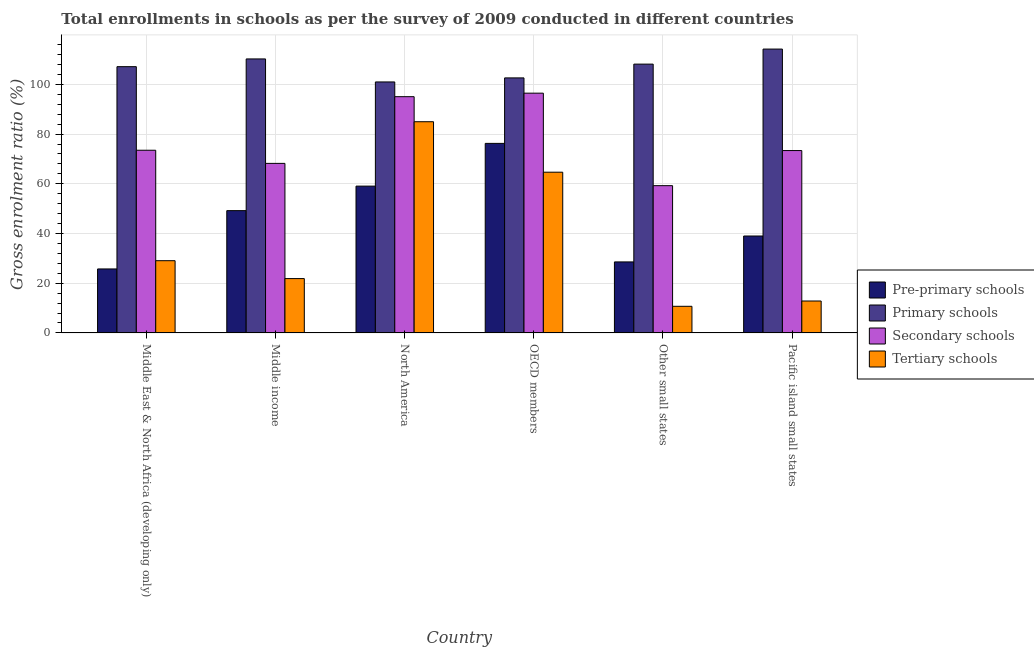How many different coloured bars are there?
Your response must be concise. 4. How many groups of bars are there?
Offer a terse response. 6. Are the number of bars per tick equal to the number of legend labels?
Ensure brevity in your answer.  Yes. Are the number of bars on each tick of the X-axis equal?
Make the answer very short. Yes. How many bars are there on the 3rd tick from the right?
Offer a very short reply. 4. What is the label of the 5th group of bars from the left?
Your answer should be very brief. Other small states. In how many cases, is the number of bars for a given country not equal to the number of legend labels?
Your response must be concise. 0. What is the gross enrolment ratio in tertiary schools in North America?
Offer a terse response. 84.97. Across all countries, what is the maximum gross enrolment ratio in tertiary schools?
Provide a succinct answer. 84.97. Across all countries, what is the minimum gross enrolment ratio in primary schools?
Offer a terse response. 100.98. In which country was the gross enrolment ratio in tertiary schools maximum?
Make the answer very short. North America. In which country was the gross enrolment ratio in pre-primary schools minimum?
Offer a terse response. Middle East & North Africa (developing only). What is the total gross enrolment ratio in secondary schools in the graph?
Offer a terse response. 465.86. What is the difference between the gross enrolment ratio in tertiary schools in Middle income and that in Pacific island small states?
Offer a terse response. 9.02. What is the difference between the gross enrolment ratio in pre-primary schools in Middle income and the gross enrolment ratio in primary schools in North America?
Ensure brevity in your answer.  -51.78. What is the average gross enrolment ratio in pre-primary schools per country?
Your answer should be compact. 46.31. What is the difference between the gross enrolment ratio in tertiary schools and gross enrolment ratio in secondary schools in OECD members?
Provide a short and direct response. -31.79. What is the ratio of the gross enrolment ratio in tertiary schools in North America to that in OECD members?
Offer a very short reply. 1.31. Is the gross enrolment ratio in pre-primary schools in Middle East & North Africa (developing only) less than that in OECD members?
Offer a very short reply. Yes. What is the difference between the highest and the second highest gross enrolment ratio in pre-primary schools?
Keep it short and to the point. 17.19. What is the difference between the highest and the lowest gross enrolment ratio in primary schools?
Provide a succinct answer. 13.22. Is the sum of the gross enrolment ratio in primary schools in Middle East & North Africa (developing only) and Middle income greater than the maximum gross enrolment ratio in pre-primary schools across all countries?
Offer a very short reply. Yes. What does the 3rd bar from the left in Other small states represents?
Offer a terse response. Secondary schools. What does the 3rd bar from the right in Pacific island small states represents?
Your answer should be compact. Primary schools. How many countries are there in the graph?
Provide a short and direct response. 6. Are the values on the major ticks of Y-axis written in scientific E-notation?
Make the answer very short. No. Does the graph contain any zero values?
Offer a very short reply. No. Does the graph contain grids?
Keep it short and to the point. Yes. What is the title of the graph?
Make the answer very short. Total enrollments in schools as per the survey of 2009 conducted in different countries. What is the label or title of the X-axis?
Offer a terse response. Country. What is the Gross enrolment ratio (%) in Pre-primary schools in Middle East & North Africa (developing only)?
Provide a succinct answer. 25.75. What is the Gross enrolment ratio (%) of Primary schools in Middle East & North Africa (developing only)?
Keep it short and to the point. 107.13. What is the Gross enrolment ratio (%) in Secondary schools in Middle East & North Africa (developing only)?
Provide a succinct answer. 73.5. What is the Gross enrolment ratio (%) in Tertiary schools in Middle East & North Africa (developing only)?
Ensure brevity in your answer.  29.06. What is the Gross enrolment ratio (%) of Pre-primary schools in Middle income?
Your response must be concise. 49.2. What is the Gross enrolment ratio (%) of Primary schools in Middle income?
Provide a short and direct response. 110.24. What is the Gross enrolment ratio (%) in Secondary schools in Middle income?
Offer a very short reply. 68.21. What is the Gross enrolment ratio (%) in Tertiary schools in Middle income?
Your answer should be compact. 21.86. What is the Gross enrolment ratio (%) in Pre-primary schools in North America?
Give a very brief answer. 59.07. What is the Gross enrolment ratio (%) of Primary schools in North America?
Ensure brevity in your answer.  100.98. What is the Gross enrolment ratio (%) in Secondary schools in North America?
Your response must be concise. 95.05. What is the Gross enrolment ratio (%) in Tertiary schools in North America?
Provide a short and direct response. 84.97. What is the Gross enrolment ratio (%) in Pre-primary schools in OECD members?
Your response must be concise. 76.26. What is the Gross enrolment ratio (%) of Primary schools in OECD members?
Provide a short and direct response. 102.61. What is the Gross enrolment ratio (%) in Secondary schools in OECD members?
Ensure brevity in your answer.  96.46. What is the Gross enrolment ratio (%) of Tertiary schools in OECD members?
Keep it short and to the point. 64.67. What is the Gross enrolment ratio (%) of Pre-primary schools in Other small states?
Your response must be concise. 28.57. What is the Gross enrolment ratio (%) in Primary schools in Other small states?
Provide a succinct answer. 108.15. What is the Gross enrolment ratio (%) of Secondary schools in Other small states?
Provide a succinct answer. 59.25. What is the Gross enrolment ratio (%) in Tertiary schools in Other small states?
Keep it short and to the point. 10.72. What is the Gross enrolment ratio (%) of Pre-primary schools in Pacific island small states?
Your response must be concise. 38.99. What is the Gross enrolment ratio (%) in Primary schools in Pacific island small states?
Your answer should be compact. 114.2. What is the Gross enrolment ratio (%) of Secondary schools in Pacific island small states?
Provide a succinct answer. 73.38. What is the Gross enrolment ratio (%) in Tertiary schools in Pacific island small states?
Provide a short and direct response. 12.84. Across all countries, what is the maximum Gross enrolment ratio (%) of Pre-primary schools?
Offer a very short reply. 76.26. Across all countries, what is the maximum Gross enrolment ratio (%) in Primary schools?
Provide a short and direct response. 114.2. Across all countries, what is the maximum Gross enrolment ratio (%) of Secondary schools?
Your answer should be very brief. 96.46. Across all countries, what is the maximum Gross enrolment ratio (%) in Tertiary schools?
Keep it short and to the point. 84.97. Across all countries, what is the minimum Gross enrolment ratio (%) in Pre-primary schools?
Provide a succinct answer. 25.75. Across all countries, what is the minimum Gross enrolment ratio (%) of Primary schools?
Your answer should be very brief. 100.98. Across all countries, what is the minimum Gross enrolment ratio (%) of Secondary schools?
Ensure brevity in your answer.  59.25. Across all countries, what is the minimum Gross enrolment ratio (%) in Tertiary schools?
Provide a succinct answer. 10.72. What is the total Gross enrolment ratio (%) in Pre-primary schools in the graph?
Your answer should be compact. 277.84. What is the total Gross enrolment ratio (%) in Primary schools in the graph?
Provide a short and direct response. 643.3. What is the total Gross enrolment ratio (%) in Secondary schools in the graph?
Offer a terse response. 465.86. What is the total Gross enrolment ratio (%) of Tertiary schools in the graph?
Ensure brevity in your answer.  224.13. What is the difference between the Gross enrolment ratio (%) of Pre-primary schools in Middle East & North Africa (developing only) and that in Middle income?
Your answer should be compact. -23.45. What is the difference between the Gross enrolment ratio (%) of Primary schools in Middle East & North Africa (developing only) and that in Middle income?
Your answer should be very brief. -3.11. What is the difference between the Gross enrolment ratio (%) in Secondary schools in Middle East & North Africa (developing only) and that in Middle income?
Offer a very short reply. 5.29. What is the difference between the Gross enrolment ratio (%) in Tertiary schools in Middle East & North Africa (developing only) and that in Middle income?
Provide a succinct answer. 7.2. What is the difference between the Gross enrolment ratio (%) of Pre-primary schools in Middle East & North Africa (developing only) and that in North America?
Provide a succinct answer. -33.32. What is the difference between the Gross enrolment ratio (%) of Primary schools in Middle East & North Africa (developing only) and that in North America?
Your answer should be very brief. 6.15. What is the difference between the Gross enrolment ratio (%) in Secondary schools in Middle East & North Africa (developing only) and that in North America?
Your response must be concise. -21.55. What is the difference between the Gross enrolment ratio (%) of Tertiary schools in Middle East & North Africa (developing only) and that in North America?
Give a very brief answer. -55.91. What is the difference between the Gross enrolment ratio (%) of Pre-primary schools in Middle East & North Africa (developing only) and that in OECD members?
Give a very brief answer. -50.51. What is the difference between the Gross enrolment ratio (%) in Primary schools in Middle East & North Africa (developing only) and that in OECD members?
Offer a very short reply. 4.52. What is the difference between the Gross enrolment ratio (%) in Secondary schools in Middle East & North Africa (developing only) and that in OECD members?
Your answer should be very brief. -22.96. What is the difference between the Gross enrolment ratio (%) of Tertiary schools in Middle East & North Africa (developing only) and that in OECD members?
Your answer should be compact. -35.61. What is the difference between the Gross enrolment ratio (%) in Pre-primary schools in Middle East & North Africa (developing only) and that in Other small states?
Offer a very short reply. -2.82. What is the difference between the Gross enrolment ratio (%) of Primary schools in Middle East & North Africa (developing only) and that in Other small states?
Make the answer very short. -1.03. What is the difference between the Gross enrolment ratio (%) in Secondary schools in Middle East & North Africa (developing only) and that in Other small states?
Offer a terse response. 14.25. What is the difference between the Gross enrolment ratio (%) of Tertiary schools in Middle East & North Africa (developing only) and that in Other small states?
Your response must be concise. 18.35. What is the difference between the Gross enrolment ratio (%) of Pre-primary schools in Middle East & North Africa (developing only) and that in Pacific island small states?
Your answer should be very brief. -13.25. What is the difference between the Gross enrolment ratio (%) of Primary schools in Middle East & North Africa (developing only) and that in Pacific island small states?
Provide a succinct answer. -7.08. What is the difference between the Gross enrolment ratio (%) of Secondary schools in Middle East & North Africa (developing only) and that in Pacific island small states?
Provide a succinct answer. 0.12. What is the difference between the Gross enrolment ratio (%) of Tertiary schools in Middle East & North Africa (developing only) and that in Pacific island small states?
Keep it short and to the point. 16.22. What is the difference between the Gross enrolment ratio (%) in Pre-primary schools in Middle income and that in North America?
Your answer should be compact. -9.87. What is the difference between the Gross enrolment ratio (%) in Primary schools in Middle income and that in North America?
Give a very brief answer. 9.26. What is the difference between the Gross enrolment ratio (%) in Secondary schools in Middle income and that in North America?
Your answer should be compact. -26.84. What is the difference between the Gross enrolment ratio (%) of Tertiary schools in Middle income and that in North America?
Provide a succinct answer. -63.11. What is the difference between the Gross enrolment ratio (%) of Pre-primary schools in Middle income and that in OECD members?
Your response must be concise. -27.06. What is the difference between the Gross enrolment ratio (%) of Primary schools in Middle income and that in OECD members?
Offer a very short reply. 7.63. What is the difference between the Gross enrolment ratio (%) in Secondary schools in Middle income and that in OECD members?
Offer a very short reply. -28.25. What is the difference between the Gross enrolment ratio (%) in Tertiary schools in Middle income and that in OECD members?
Offer a very short reply. -42.8. What is the difference between the Gross enrolment ratio (%) in Pre-primary schools in Middle income and that in Other small states?
Provide a short and direct response. 20.63. What is the difference between the Gross enrolment ratio (%) of Primary schools in Middle income and that in Other small states?
Provide a succinct answer. 2.09. What is the difference between the Gross enrolment ratio (%) in Secondary schools in Middle income and that in Other small states?
Your answer should be very brief. 8.96. What is the difference between the Gross enrolment ratio (%) of Tertiary schools in Middle income and that in Other small states?
Your response must be concise. 11.15. What is the difference between the Gross enrolment ratio (%) of Pre-primary schools in Middle income and that in Pacific island small states?
Make the answer very short. 10.21. What is the difference between the Gross enrolment ratio (%) of Primary schools in Middle income and that in Pacific island small states?
Your response must be concise. -3.97. What is the difference between the Gross enrolment ratio (%) in Secondary schools in Middle income and that in Pacific island small states?
Your response must be concise. -5.17. What is the difference between the Gross enrolment ratio (%) in Tertiary schools in Middle income and that in Pacific island small states?
Keep it short and to the point. 9.02. What is the difference between the Gross enrolment ratio (%) in Pre-primary schools in North America and that in OECD members?
Provide a succinct answer. -17.19. What is the difference between the Gross enrolment ratio (%) in Primary schools in North America and that in OECD members?
Your answer should be compact. -1.63. What is the difference between the Gross enrolment ratio (%) of Secondary schools in North America and that in OECD members?
Provide a short and direct response. -1.41. What is the difference between the Gross enrolment ratio (%) of Tertiary schools in North America and that in OECD members?
Provide a succinct answer. 20.31. What is the difference between the Gross enrolment ratio (%) in Pre-primary schools in North America and that in Other small states?
Provide a short and direct response. 30.5. What is the difference between the Gross enrolment ratio (%) in Primary schools in North America and that in Other small states?
Offer a terse response. -7.17. What is the difference between the Gross enrolment ratio (%) in Secondary schools in North America and that in Other small states?
Give a very brief answer. 35.8. What is the difference between the Gross enrolment ratio (%) in Tertiary schools in North America and that in Other small states?
Offer a terse response. 74.26. What is the difference between the Gross enrolment ratio (%) of Pre-primary schools in North America and that in Pacific island small states?
Provide a succinct answer. 20.07. What is the difference between the Gross enrolment ratio (%) of Primary schools in North America and that in Pacific island small states?
Keep it short and to the point. -13.22. What is the difference between the Gross enrolment ratio (%) of Secondary schools in North America and that in Pacific island small states?
Provide a short and direct response. 21.67. What is the difference between the Gross enrolment ratio (%) in Tertiary schools in North America and that in Pacific island small states?
Provide a short and direct response. 72.13. What is the difference between the Gross enrolment ratio (%) of Pre-primary schools in OECD members and that in Other small states?
Keep it short and to the point. 47.69. What is the difference between the Gross enrolment ratio (%) of Primary schools in OECD members and that in Other small states?
Your response must be concise. -5.54. What is the difference between the Gross enrolment ratio (%) in Secondary schools in OECD members and that in Other small states?
Keep it short and to the point. 37.21. What is the difference between the Gross enrolment ratio (%) of Tertiary schools in OECD members and that in Other small states?
Your response must be concise. 53.95. What is the difference between the Gross enrolment ratio (%) in Pre-primary schools in OECD members and that in Pacific island small states?
Your answer should be compact. 37.27. What is the difference between the Gross enrolment ratio (%) in Primary schools in OECD members and that in Pacific island small states?
Ensure brevity in your answer.  -11.6. What is the difference between the Gross enrolment ratio (%) in Secondary schools in OECD members and that in Pacific island small states?
Offer a terse response. 23.08. What is the difference between the Gross enrolment ratio (%) of Tertiary schools in OECD members and that in Pacific island small states?
Offer a very short reply. 51.82. What is the difference between the Gross enrolment ratio (%) in Pre-primary schools in Other small states and that in Pacific island small states?
Offer a terse response. -10.42. What is the difference between the Gross enrolment ratio (%) in Primary schools in Other small states and that in Pacific island small states?
Ensure brevity in your answer.  -6.05. What is the difference between the Gross enrolment ratio (%) in Secondary schools in Other small states and that in Pacific island small states?
Your response must be concise. -14.13. What is the difference between the Gross enrolment ratio (%) in Tertiary schools in Other small states and that in Pacific island small states?
Ensure brevity in your answer.  -2.13. What is the difference between the Gross enrolment ratio (%) in Pre-primary schools in Middle East & North Africa (developing only) and the Gross enrolment ratio (%) in Primary schools in Middle income?
Provide a succinct answer. -84.49. What is the difference between the Gross enrolment ratio (%) in Pre-primary schools in Middle East & North Africa (developing only) and the Gross enrolment ratio (%) in Secondary schools in Middle income?
Offer a terse response. -42.46. What is the difference between the Gross enrolment ratio (%) of Pre-primary schools in Middle East & North Africa (developing only) and the Gross enrolment ratio (%) of Tertiary schools in Middle income?
Make the answer very short. 3.88. What is the difference between the Gross enrolment ratio (%) of Primary schools in Middle East & North Africa (developing only) and the Gross enrolment ratio (%) of Secondary schools in Middle income?
Provide a succinct answer. 38.91. What is the difference between the Gross enrolment ratio (%) in Primary schools in Middle East & North Africa (developing only) and the Gross enrolment ratio (%) in Tertiary schools in Middle income?
Provide a short and direct response. 85.26. What is the difference between the Gross enrolment ratio (%) of Secondary schools in Middle East & North Africa (developing only) and the Gross enrolment ratio (%) of Tertiary schools in Middle income?
Offer a very short reply. 51.64. What is the difference between the Gross enrolment ratio (%) in Pre-primary schools in Middle East & North Africa (developing only) and the Gross enrolment ratio (%) in Primary schools in North America?
Make the answer very short. -75.23. What is the difference between the Gross enrolment ratio (%) of Pre-primary schools in Middle East & North Africa (developing only) and the Gross enrolment ratio (%) of Secondary schools in North America?
Your response must be concise. -69.3. What is the difference between the Gross enrolment ratio (%) in Pre-primary schools in Middle East & North Africa (developing only) and the Gross enrolment ratio (%) in Tertiary schools in North America?
Ensure brevity in your answer.  -59.23. What is the difference between the Gross enrolment ratio (%) in Primary schools in Middle East & North Africa (developing only) and the Gross enrolment ratio (%) in Secondary schools in North America?
Make the answer very short. 12.07. What is the difference between the Gross enrolment ratio (%) of Primary schools in Middle East & North Africa (developing only) and the Gross enrolment ratio (%) of Tertiary schools in North America?
Your answer should be very brief. 22.15. What is the difference between the Gross enrolment ratio (%) in Secondary schools in Middle East & North Africa (developing only) and the Gross enrolment ratio (%) in Tertiary schools in North America?
Provide a short and direct response. -11.47. What is the difference between the Gross enrolment ratio (%) of Pre-primary schools in Middle East & North Africa (developing only) and the Gross enrolment ratio (%) of Primary schools in OECD members?
Keep it short and to the point. -76.86. What is the difference between the Gross enrolment ratio (%) of Pre-primary schools in Middle East & North Africa (developing only) and the Gross enrolment ratio (%) of Secondary schools in OECD members?
Keep it short and to the point. -70.71. What is the difference between the Gross enrolment ratio (%) of Pre-primary schools in Middle East & North Africa (developing only) and the Gross enrolment ratio (%) of Tertiary schools in OECD members?
Provide a short and direct response. -38.92. What is the difference between the Gross enrolment ratio (%) in Primary schools in Middle East & North Africa (developing only) and the Gross enrolment ratio (%) in Secondary schools in OECD members?
Keep it short and to the point. 10.66. What is the difference between the Gross enrolment ratio (%) of Primary schools in Middle East & North Africa (developing only) and the Gross enrolment ratio (%) of Tertiary schools in OECD members?
Your response must be concise. 42.46. What is the difference between the Gross enrolment ratio (%) in Secondary schools in Middle East & North Africa (developing only) and the Gross enrolment ratio (%) in Tertiary schools in OECD members?
Offer a very short reply. 8.83. What is the difference between the Gross enrolment ratio (%) of Pre-primary schools in Middle East & North Africa (developing only) and the Gross enrolment ratio (%) of Primary schools in Other small states?
Your answer should be very brief. -82.4. What is the difference between the Gross enrolment ratio (%) of Pre-primary schools in Middle East & North Africa (developing only) and the Gross enrolment ratio (%) of Secondary schools in Other small states?
Provide a succinct answer. -33.5. What is the difference between the Gross enrolment ratio (%) in Pre-primary schools in Middle East & North Africa (developing only) and the Gross enrolment ratio (%) in Tertiary schools in Other small states?
Keep it short and to the point. 15.03. What is the difference between the Gross enrolment ratio (%) of Primary schools in Middle East & North Africa (developing only) and the Gross enrolment ratio (%) of Secondary schools in Other small states?
Offer a very short reply. 47.87. What is the difference between the Gross enrolment ratio (%) in Primary schools in Middle East & North Africa (developing only) and the Gross enrolment ratio (%) in Tertiary schools in Other small states?
Keep it short and to the point. 96.41. What is the difference between the Gross enrolment ratio (%) of Secondary schools in Middle East & North Africa (developing only) and the Gross enrolment ratio (%) of Tertiary schools in Other small states?
Offer a very short reply. 62.78. What is the difference between the Gross enrolment ratio (%) of Pre-primary schools in Middle East & North Africa (developing only) and the Gross enrolment ratio (%) of Primary schools in Pacific island small states?
Your response must be concise. -88.46. What is the difference between the Gross enrolment ratio (%) in Pre-primary schools in Middle East & North Africa (developing only) and the Gross enrolment ratio (%) in Secondary schools in Pacific island small states?
Ensure brevity in your answer.  -47.63. What is the difference between the Gross enrolment ratio (%) of Pre-primary schools in Middle East & North Africa (developing only) and the Gross enrolment ratio (%) of Tertiary schools in Pacific island small states?
Your answer should be very brief. 12.9. What is the difference between the Gross enrolment ratio (%) in Primary schools in Middle East & North Africa (developing only) and the Gross enrolment ratio (%) in Secondary schools in Pacific island small states?
Provide a succinct answer. 33.75. What is the difference between the Gross enrolment ratio (%) of Primary schools in Middle East & North Africa (developing only) and the Gross enrolment ratio (%) of Tertiary schools in Pacific island small states?
Offer a terse response. 94.28. What is the difference between the Gross enrolment ratio (%) in Secondary schools in Middle East & North Africa (developing only) and the Gross enrolment ratio (%) in Tertiary schools in Pacific island small states?
Your answer should be compact. 60.66. What is the difference between the Gross enrolment ratio (%) of Pre-primary schools in Middle income and the Gross enrolment ratio (%) of Primary schools in North America?
Provide a short and direct response. -51.78. What is the difference between the Gross enrolment ratio (%) in Pre-primary schools in Middle income and the Gross enrolment ratio (%) in Secondary schools in North America?
Offer a terse response. -45.85. What is the difference between the Gross enrolment ratio (%) of Pre-primary schools in Middle income and the Gross enrolment ratio (%) of Tertiary schools in North America?
Offer a terse response. -35.77. What is the difference between the Gross enrolment ratio (%) of Primary schools in Middle income and the Gross enrolment ratio (%) of Secondary schools in North America?
Your response must be concise. 15.19. What is the difference between the Gross enrolment ratio (%) in Primary schools in Middle income and the Gross enrolment ratio (%) in Tertiary schools in North America?
Make the answer very short. 25.26. What is the difference between the Gross enrolment ratio (%) in Secondary schools in Middle income and the Gross enrolment ratio (%) in Tertiary schools in North America?
Ensure brevity in your answer.  -16.76. What is the difference between the Gross enrolment ratio (%) in Pre-primary schools in Middle income and the Gross enrolment ratio (%) in Primary schools in OECD members?
Give a very brief answer. -53.4. What is the difference between the Gross enrolment ratio (%) of Pre-primary schools in Middle income and the Gross enrolment ratio (%) of Secondary schools in OECD members?
Keep it short and to the point. -47.26. What is the difference between the Gross enrolment ratio (%) of Pre-primary schools in Middle income and the Gross enrolment ratio (%) of Tertiary schools in OECD members?
Ensure brevity in your answer.  -15.47. What is the difference between the Gross enrolment ratio (%) of Primary schools in Middle income and the Gross enrolment ratio (%) of Secondary schools in OECD members?
Your answer should be very brief. 13.78. What is the difference between the Gross enrolment ratio (%) of Primary schools in Middle income and the Gross enrolment ratio (%) of Tertiary schools in OECD members?
Give a very brief answer. 45.57. What is the difference between the Gross enrolment ratio (%) of Secondary schools in Middle income and the Gross enrolment ratio (%) of Tertiary schools in OECD members?
Give a very brief answer. 3.54. What is the difference between the Gross enrolment ratio (%) in Pre-primary schools in Middle income and the Gross enrolment ratio (%) in Primary schools in Other small states?
Give a very brief answer. -58.95. What is the difference between the Gross enrolment ratio (%) of Pre-primary schools in Middle income and the Gross enrolment ratio (%) of Secondary schools in Other small states?
Provide a succinct answer. -10.05. What is the difference between the Gross enrolment ratio (%) in Pre-primary schools in Middle income and the Gross enrolment ratio (%) in Tertiary schools in Other small states?
Your response must be concise. 38.49. What is the difference between the Gross enrolment ratio (%) of Primary schools in Middle income and the Gross enrolment ratio (%) of Secondary schools in Other small states?
Offer a terse response. 50.99. What is the difference between the Gross enrolment ratio (%) in Primary schools in Middle income and the Gross enrolment ratio (%) in Tertiary schools in Other small states?
Make the answer very short. 99.52. What is the difference between the Gross enrolment ratio (%) of Secondary schools in Middle income and the Gross enrolment ratio (%) of Tertiary schools in Other small states?
Offer a terse response. 57.49. What is the difference between the Gross enrolment ratio (%) in Pre-primary schools in Middle income and the Gross enrolment ratio (%) in Primary schools in Pacific island small states?
Make the answer very short. -65. What is the difference between the Gross enrolment ratio (%) in Pre-primary schools in Middle income and the Gross enrolment ratio (%) in Secondary schools in Pacific island small states?
Offer a very short reply. -24.18. What is the difference between the Gross enrolment ratio (%) of Pre-primary schools in Middle income and the Gross enrolment ratio (%) of Tertiary schools in Pacific island small states?
Your answer should be very brief. 36.36. What is the difference between the Gross enrolment ratio (%) in Primary schools in Middle income and the Gross enrolment ratio (%) in Secondary schools in Pacific island small states?
Ensure brevity in your answer.  36.86. What is the difference between the Gross enrolment ratio (%) of Primary schools in Middle income and the Gross enrolment ratio (%) of Tertiary schools in Pacific island small states?
Provide a succinct answer. 97.39. What is the difference between the Gross enrolment ratio (%) in Secondary schools in Middle income and the Gross enrolment ratio (%) in Tertiary schools in Pacific island small states?
Your answer should be compact. 55.37. What is the difference between the Gross enrolment ratio (%) of Pre-primary schools in North America and the Gross enrolment ratio (%) of Primary schools in OECD members?
Offer a terse response. -43.54. What is the difference between the Gross enrolment ratio (%) of Pre-primary schools in North America and the Gross enrolment ratio (%) of Secondary schools in OECD members?
Keep it short and to the point. -37.39. What is the difference between the Gross enrolment ratio (%) in Pre-primary schools in North America and the Gross enrolment ratio (%) in Tertiary schools in OECD members?
Offer a terse response. -5.6. What is the difference between the Gross enrolment ratio (%) of Primary schools in North America and the Gross enrolment ratio (%) of Secondary schools in OECD members?
Provide a short and direct response. 4.52. What is the difference between the Gross enrolment ratio (%) in Primary schools in North America and the Gross enrolment ratio (%) in Tertiary schools in OECD members?
Keep it short and to the point. 36.31. What is the difference between the Gross enrolment ratio (%) in Secondary schools in North America and the Gross enrolment ratio (%) in Tertiary schools in OECD members?
Keep it short and to the point. 30.38. What is the difference between the Gross enrolment ratio (%) of Pre-primary schools in North America and the Gross enrolment ratio (%) of Primary schools in Other small states?
Provide a succinct answer. -49.08. What is the difference between the Gross enrolment ratio (%) of Pre-primary schools in North America and the Gross enrolment ratio (%) of Secondary schools in Other small states?
Provide a succinct answer. -0.18. What is the difference between the Gross enrolment ratio (%) of Pre-primary schools in North America and the Gross enrolment ratio (%) of Tertiary schools in Other small states?
Offer a terse response. 48.35. What is the difference between the Gross enrolment ratio (%) in Primary schools in North America and the Gross enrolment ratio (%) in Secondary schools in Other small states?
Make the answer very short. 41.73. What is the difference between the Gross enrolment ratio (%) of Primary schools in North America and the Gross enrolment ratio (%) of Tertiary schools in Other small states?
Ensure brevity in your answer.  90.26. What is the difference between the Gross enrolment ratio (%) in Secondary schools in North America and the Gross enrolment ratio (%) in Tertiary schools in Other small states?
Offer a very short reply. 84.33. What is the difference between the Gross enrolment ratio (%) in Pre-primary schools in North America and the Gross enrolment ratio (%) in Primary schools in Pacific island small states?
Keep it short and to the point. -55.14. What is the difference between the Gross enrolment ratio (%) of Pre-primary schools in North America and the Gross enrolment ratio (%) of Secondary schools in Pacific island small states?
Make the answer very short. -14.31. What is the difference between the Gross enrolment ratio (%) in Pre-primary schools in North America and the Gross enrolment ratio (%) in Tertiary schools in Pacific island small states?
Give a very brief answer. 46.22. What is the difference between the Gross enrolment ratio (%) of Primary schools in North America and the Gross enrolment ratio (%) of Secondary schools in Pacific island small states?
Ensure brevity in your answer.  27.6. What is the difference between the Gross enrolment ratio (%) in Primary schools in North America and the Gross enrolment ratio (%) in Tertiary schools in Pacific island small states?
Keep it short and to the point. 88.14. What is the difference between the Gross enrolment ratio (%) of Secondary schools in North America and the Gross enrolment ratio (%) of Tertiary schools in Pacific island small states?
Ensure brevity in your answer.  82.21. What is the difference between the Gross enrolment ratio (%) of Pre-primary schools in OECD members and the Gross enrolment ratio (%) of Primary schools in Other small states?
Your response must be concise. -31.89. What is the difference between the Gross enrolment ratio (%) in Pre-primary schools in OECD members and the Gross enrolment ratio (%) in Secondary schools in Other small states?
Your response must be concise. 17.01. What is the difference between the Gross enrolment ratio (%) of Pre-primary schools in OECD members and the Gross enrolment ratio (%) of Tertiary schools in Other small states?
Provide a succinct answer. 65.54. What is the difference between the Gross enrolment ratio (%) of Primary schools in OECD members and the Gross enrolment ratio (%) of Secondary schools in Other small states?
Your answer should be very brief. 43.36. What is the difference between the Gross enrolment ratio (%) in Primary schools in OECD members and the Gross enrolment ratio (%) in Tertiary schools in Other small states?
Your response must be concise. 91.89. What is the difference between the Gross enrolment ratio (%) of Secondary schools in OECD members and the Gross enrolment ratio (%) of Tertiary schools in Other small states?
Provide a succinct answer. 85.74. What is the difference between the Gross enrolment ratio (%) in Pre-primary schools in OECD members and the Gross enrolment ratio (%) in Primary schools in Pacific island small states?
Provide a short and direct response. -37.94. What is the difference between the Gross enrolment ratio (%) in Pre-primary schools in OECD members and the Gross enrolment ratio (%) in Secondary schools in Pacific island small states?
Give a very brief answer. 2.88. What is the difference between the Gross enrolment ratio (%) of Pre-primary schools in OECD members and the Gross enrolment ratio (%) of Tertiary schools in Pacific island small states?
Provide a succinct answer. 63.41. What is the difference between the Gross enrolment ratio (%) of Primary schools in OECD members and the Gross enrolment ratio (%) of Secondary schools in Pacific island small states?
Give a very brief answer. 29.23. What is the difference between the Gross enrolment ratio (%) in Primary schools in OECD members and the Gross enrolment ratio (%) in Tertiary schools in Pacific island small states?
Provide a succinct answer. 89.76. What is the difference between the Gross enrolment ratio (%) in Secondary schools in OECD members and the Gross enrolment ratio (%) in Tertiary schools in Pacific island small states?
Give a very brief answer. 83.62. What is the difference between the Gross enrolment ratio (%) of Pre-primary schools in Other small states and the Gross enrolment ratio (%) of Primary schools in Pacific island small states?
Provide a succinct answer. -85.63. What is the difference between the Gross enrolment ratio (%) in Pre-primary schools in Other small states and the Gross enrolment ratio (%) in Secondary schools in Pacific island small states?
Give a very brief answer. -44.81. What is the difference between the Gross enrolment ratio (%) of Pre-primary schools in Other small states and the Gross enrolment ratio (%) of Tertiary schools in Pacific island small states?
Give a very brief answer. 15.73. What is the difference between the Gross enrolment ratio (%) of Primary schools in Other small states and the Gross enrolment ratio (%) of Secondary schools in Pacific island small states?
Your answer should be very brief. 34.77. What is the difference between the Gross enrolment ratio (%) of Primary schools in Other small states and the Gross enrolment ratio (%) of Tertiary schools in Pacific island small states?
Offer a terse response. 95.31. What is the difference between the Gross enrolment ratio (%) of Secondary schools in Other small states and the Gross enrolment ratio (%) of Tertiary schools in Pacific island small states?
Provide a succinct answer. 46.41. What is the average Gross enrolment ratio (%) in Pre-primary schools per country?
Keep it short and to the point. 46.31. What is the average Gross enrolment ratio (%) of Primary schools per country?
Ensure brevity in your answer.  107.22. What is the average Gross enrolment ratio (%) of Secondary schools per country?
Offer a very short reply. 77.64. What is the average Gross enrolment ratio (%) in Tertiary schools per country?
Give a very brief answer. 37.36. What is the difference between the Gross enrolment ratio (%) of Pre-primary schools and Gross enrolment ratio (%) of Primary schools in Middle East & North Africa (developing only)?
Provide a short and direct response. -81.38. What is the difference between the Gross enrolment ratio (%) in Pre-primary schools and Gross enrolment ratio (%) in Secondary schools in Middle East & North Africa (developing only)?
Provide a short and direct response. -47.75. What is the difference between the Gross enrolment ratio (%) of Pre-primary schools and Gross enrolment ratio (%) of Tertiary schools in Middle East & North Africa (developing only)?
Offer a terse response. -3.32. What is the difference between the Gross enrolment ratio (%) in Primary schools and Gross enrolment ratio (%) in Secondary schools in Middle East & North Africa (developing only)?
Make the answer very short. 33.62. What is the difference between the Gross enrolment ratio (%) of Primary schools and Gross enrolment ratio (%) of Tertiary schools in Middle East & North Africa (developing only)?
Offer a very short reply. 78.06. What is the difference between the Gross enrolment ratio (%) in Secondary schools and Gross enrolment ratio (%) in Tertiary schools in Middle East & North Africa (developing only)?
Your answer should be compact. 44.44. What is the difference between the Gross enrolment ratio (%) of Pre-primary schools and Gross enrolment ratio (%) of Primary schools in Middle income?
Provide a succinct answer. -61.03. What is the difference between the Gross enrolment ratio (%) of Pre-primary schools and Gross enrolment ratio (%) of Secondary schools in Middle income?
Provide a succinct answer. -19.01. What is the difference between the Gross enrolment ratio (%) in Pre-primary schools and Gross enrolment ratio (%) in Tertiary schools in Middle income?
Offer a very short reply. 27.34. What is the difference between the Gross enrolment ratio (%) of Primary schools and Gross enrolment ratio (%) of Secondary schools in Middle income?
Provide a short and direct response. 42.03. What is the difference between the Gross enrolment ratio (%) in Primary schools and Gross enrolment ratio (%) in Tertiary schools in Middle income?
Provide a succinct answer. 88.37. What is the difference between the Gross enrolment ratio (%) of Secondary schools and Gross enrolment ratio (%) of Tertiary schools in Middle income?
Your answer should be compact. 46.35. What is the difference between the Gross enrolment ratio (%) of Pre-primary schools and Gross enrolment ratio (%) of Primary schools in North America?
Ensure brevity in your answer.  -41.91. What is the difference between the Gross enrolment ratio (%) of Pre-primary schools and Gross enrolment ratio (%) of Secondary schools in North America?
Offer a very short reply. -35.98. What is the difference between the Gross enrolment ratio (%) of Pre-primary schools and Gross enrolment ratio (%) of Tertiary schools in North America?
Ensure brevity in your answer.  -25.91. What is the difference between the Gross enrolment ratio (%) of Primary schools and Gross enrolment ratio (%) of Secondary schools in North America?
Your answer should be compact. 5.93. What is the difference between the Gross enrolment ratio (%) of Primary schools and Gross enrolment ratio (%) of Tertiary schools in North America?
Your response must be concise. 16. What is the difference between the Gross enrolment ratio (%) in Secondary schools and Gross enrolment ratio (%) in Tertiary schools in North America?
Keep it short and to the point. 10.08. What is the difference between the Gross enrolment ratio (%) in Pre-primary schools and Gross enrolment ratio (%) in Primary schools in OECD members?
Offer a very short reply. -26.35. What is the difference between the Gross enrolment ratio (%) of Pre-primary schools and Gross enrolment ratio (%) of Secondary schools in OECD members?
Provide a short and direct response. -20.2. What is the difference between the Gross enrolment ratio (%) of Pre-primary schools and Gross enrolment ratio (%) of Tertiary schools in OECD members?
Provide a short and direct response. 11.59. What is the difference between the Gross enrolment ratio (%) in Primary schools and Gross enrolment ratio (%) in Secondary schools in OECD members?
Your answer should be very brief. 6.15. What is the difference between the Gross enrolment ratio (%) in Primary schools and Gross enrolment ratio (%) in Tertiary schools in OECD members?
Provide a succinct answer. 37.94. What is the difference between the Gross enrolment ratio (%) in Secondary schools and Gross enrolment ratio (%) in Tertiary schools in OECD members?
Your answer should be very brief. 31.79. What is the difference between the Gross enrolment ratio (%) in Pre-primary schools and Gross enrolment ratio (%) in Primary schools in Other small states?
Offer a terse response. -79.58. What is the difference between the Gross enrolment ratio (%) in Pre-primary schools and Gross enrolment ratio (%) in Secondary schools in Other small states?
Give a very brief answer. -30.68. What is the difference between the Gross enrolment ratio (%) in Pre-primary schools and Gross enrolment ratio (%) in Tertiary schools in Other small states?
Keep it short and to the point. 17.85. What is the difference between the Gross enrolment ratio (%) of Primary schools and Gross enrolment ratio (%) of Secondary schools in Other small states?
Your answer should be very brief. 48.9. What is the difference between the Gross enrolment ratio (%) in Primary schools and Gross enrolment ratio (%) in Tertiary schools in Other small states?
Provide a short and direct response. 97.43. What is the difference between the Gross enrolment ratio (%) in Secondary schools and Gross enrolment ratio (%) in Tertiary schools in Other small states?
Make the answer very short. 48.53. What is the difference between the Gross enrolment ratio (%) of Pre-primary schools and Gross enrolment ratio (%) of Primary schools in Pacific island small states?
Offer a terse response. -75.21. What is the difference between the Gross enrolment ratio (%) in Pre-primary schools and Gross enrolment ratio (%) in Secondary schools in Pacific island small states?
Offer a terse response. -34.38. What is the difference between the Gross enrolment ratio (%) in Pre-primary schools and Gross enrolment ratio (%) in Tertiary schools in Pacific island small states?
Offer a terse response. 26.15. What is the difference between the Gross enrolment ratio (%) of Primary schools and Gross enrolment ratio (%) of Secondary schools in Pacific island small states?
Keep it short and to the point. 40.83. What is the difference between the Gross enrolment ratio (%) of Primary schools and Gross enrolment ratio (%) of Tertiary schools in Pacific island small states?
Offer a terse response. 101.36. What is the difference between the Gross enrolment ratio (%) of Secondary schools and Gross enrolment ratio (%) of Tertiary schools in Pacific island small states?
Keep it short and to the point. 60.53. What is the ratio of the Gross enrolment ratio (%) of Pre-primary schools in Middle East & North Africa (developing only) to that in Middle income?
Your answer should be compact. 0.52. What is the ratio of the Gross enrolment ratio (%) of Primary schools in Middle East & North Africa (developing only) to that in Middle income?
Your response must be concise. 0.97. What is the ratio of the Gross enrolment ratio (%) of Secondary schools in Middle East & North Africa (developing only) to that in Middle income?
Your answer should be compact. 1.08. What is the ratio of the Gross enrolment ratio (%) in Tertiary schools in Middle East & North Africa (developing only) to that in Middle income?
Keep it short and to the point. 1.33. What is the ratio of the Gross enrolment ratio (%) in Pre-primary schools in Middle East & North Africa (developing only) to that in North America?
Make the answer very short. 0.44. What is the ratio of the Gross enrolment ratio (%) in Primary schools in Middle East & North Africa (developing only) to that in North America?
Your answer should be very brief. 1.06. What is the ratio of the Gross enrolment ratio (%) of Secondary schools in Middle East & North Africa (developing only) to that in North America?
Provide a short and direct response. 0.77. What is the ratio of the Gross enrolment ratio (%) in Tertiary schools in Middle East & North Africa (developing only) to that in North America?
Provide a succinct answer. 0.34. What is the ratio of the Gross enrolment ratio (%) in Pre-primary schools in Middle East & North Africa (developing only) to that in OECD members?
Your response must be concise. 0.34. What is the ratio of the Gross enrolment ratio (%) in Primary schools in Middle East & North Africa (developing only) to that in OECD members?
Provide a short and direct response. 1.04. What is the ratio of the Gross enrolment ratio (%) of Secondary schools in Middle East & North Africa (developing only) to that in OECD members?
Provide a succinct answer. 0.76. What is the ratio of the Gross enrolment ratio (%) of Tertiary schools in Middle East & North Africa (developing only) to that in OECD members?
Provide a succinct answer. 0.45. What is the ratio of the Gross enrolment ratio (%) of Pre-primary schools in Middle East & North Africa (developing only) to that in Other small states?
Your response must be concise. 0.9. What is the ratio of the Gross enrolment ratio (%) in Secondary schools in Middle East & North Africa (developing only) to that in Other small states?
Keep it short and to the point. 1.24. What is the ratio of the Gross enrolment ratio (%) of Tertiary schools in Middle East & North Africa (developing only) to that in Other small states?
Offer a very short reply. 2.71. What is the ratio of the Gross enrolment ratio (%) in Pre-primary schools in Middle East & North Africa (developing only) to that in Pacific island small states?
Offer a terse response. 0.66. What is the ratio of the Gross enrolment ratio (%) of Primary schools in Middle East & North Africa (developing only) to that in Pacific island small states?
Provide a short and direct response. 0.94. What is the ratio of the Gross enrolment ratio (%) in Tertiary schools in Middle East & North Africa (developing only) to that in Pacific island small states?
Offer a very short reply. 2.26. What is the ratio of the Gross enrolment ratio (%) of Pre-primary schools in Middle income to that in North America?
Provide a succinct answer. 0.83. What is the ratio of the Gross enrolment ratio (%) in Primary schools in Middle income to that in North America?
Your response must be concise. 1.09. What is the ratio of the Gross enrolment ratio (%) of Secondary schools in Middle income to that in North America?
Provide a short and direct response. 0.72. What is the ratio of the Gross enrolment ratio (%) in Tertiary schools in Middle income to that in North America?
Your answer should be very brief. 0.26. What is the ratio of the Gross enrolment ratio (%) in Pre-primary schools in Middle income to that in OECD members?
Your answer should be compact. 0.65. What is the ratio of the Gross enrolment ratio (%) of Primary schools in Middle income to that in OECD members?
Your response must be concise. 1.07. What is the ratio of the Gross enrolment ratio (%) in Secondary schools in Middle income to that in OECD members?
Keep it short and to the point. 0.71. What is the ratio of the Gross enrolment ratio (%) in Tertiary schools in Middle income to that in OECD members?
Keep it short and to the point. 0.34. What is the ratio of the Gross enrolment ratio (%) of Pre-primary schools in Middle income to that in Other small states?
Your answer should be compact. 1.72. What is the ratio of the Gross enrolment ratio (%) of Primary schools in Middle income to that in Other small states?
Offer a terse response. 1.02. What is the ratio of the Gross enrolment ratio (%) of Secondary schools in Middle income to that in Other small states?
Your answer should be compact. 1.15. What is the ratio of the Gross enrolment ratio (%) in Tertiary schools in Middle income to that in Other small states?
Keep it short and to the point. 2.04. What is the ratio of the Gross enrolment ratio (%) in Pre-primary schools in Middle income to that in Pacific island small states?
Make the answer very short. 1.26. What is the ratio of the Gross enrolment ratio (%) of Primary schools in Middle income to that in Pacific island small states?
Offer a terse response. 0.97. What is the ratio of the Gross enrolment ratio (%) in Secondary schools in Middle income to that in Pacific island small states?
Provide a succinct answer. 0.93. What is the ratio of the Gross enrolment ratio (%) in Tertiary schools in Middle income to that in Pacific island small states?
Offer a terse response. 1.7. What is the ratio of the Gross enrolment ratio (%) in Pre-primary schools in North America to that in OECD members?
Your response must be concise. 0.77. What is the ratio of the Gross enrolment ratio (%) in Primary schools in North America to that in OECD members?
Offer a terse response. 0.98. What is the ratio of the Gross enrolment ratio (%) of Secondary schools in North America to that in OECD members?
Your answer should be very brief. 0.99. What is the ratio of the Gross enrolment ratio (%) in Tertiary schools in North America to that in OECD members?
Your answer should be compact. 1.31. What is the ratio of the Gross enrolment ratio (%) in Pre-primary schools in North America to that in Other small states?
Make the answer very short. 2.07. What is the ratio of the Gross enrolment ratio (%) in Primary schools in North America to that in Other small states?
Provide a succinct answer. 0.93. What is the ratio of the Gross enrolment ratio (%) in Secondary schools in North America to that in Other small states?
Offer a very short reply. 1.6. What is the ratio of the Gross enrolment ratio (%) of Tertiary schools in North America to that in Other small states?
Ensure brevity in your answer.  7.93. What is the ratio of the Gross enrolment ratio (%) in Pre-primary schools in North America to that in Pacific island small states?
Keep it short and to the point. 1.51. What is the ratio of the Gross enrolment ratio (%) in Primary schools in North America to that in Pacific island small states?
Offer a very short reply. 0.88. What is the ratio of the Gross enrolment ratio (%) of Secondary schools in North America to that in Pacific island small states?
Offer a terse response. 1.3. What is the ratio of the Gross enrolment ratio (%) in Tertiary schools in North America to that in Pacific island small states?
Your answer should be compact. 6.62. What is the ratio of the Gross enrolment ratio (%) of Pre-primary schools in OECD members to that in Other small states?
Your response must be concise. 2.67. What is the ratio of the Gross enrolment ratio (%) in Primary schools in OECD members to that in Other small states?
Provide a short and direct response. 0.95. What is the ratio of the Gross enrolment ratio (%) in Secondary schools in OECD members to that in Other small states?
Give a very brief answer. 1.63. What is the ratio of the Gross enrolment ratio (%) of Tertiary schools in OECD members to that in Other small states?
Give a very brief answer. 6.03. What is the ratio of the Gross enrolment ratio (%) in Pre-primary schools in OECD members to that in Pacific island small states?
Provide a succinct answer. 1.96. What is the ratio of the Gross enrolment ratio (%) in Primary schools in OECD members to that in Pacific island small states?
Offer a very short reply. 0.9. What is the ratio of the Gross enrolment ratio (%) of Secondary schools in OECD members to that in Pacific island small states?
Provide a succinct answer. 1.31. What is the ratio of the Gross enrolment ratio (%) of Tertiary schools in OECD members to that in Pacific island small states?
Your answer should be very brief. 5.04. What is the ratio of the Gross enrolment ratio (%) of Pre-primary schools in Other small states to that in Pacific island small states?
Your response must be concise. 0.73. What is the ratio of the Gross enrolment ratio (%) of Primary schools in Other small states to that in Pacific island small states?
Offer a terse response. 0.95. What is the ratio of the Gross enrolment ratio (%) in Secondary schools in Other small states to that in Pacific island small states?
Your answer should be compact. 0.81. What is the ratio of the Gross enrolment ratio (%) in Tertiary schools in Other small states to that in Pacific island small states?
Keep it short and to the point. 0.83. What is the difference between the highest and the second highest Gross enrolment ratio (%) of Pre-primary schools?
Your answer should be very brief. 17.19. What is the difference between the highest and the second highest Gross enrolment ratio (%) of Primary schools?
Your response must be concise. 3.97. What is the difference between the highest and the second highest Gross enrolment ratio (%) of Secondary schools?
Provide a succinct answer. 1.41. What is the difference between the highest and the second highest Gross enrolment ratio (%) in Tertiary schools?
Make the answer very short. 20.31. What is the difference between the highest and the lowest Gross enrolment ratio (%) in Pre-primary schools?
Your answer should be very brief. 50.51. What is the difference between the highest and the lowest Gross enrolment ratio (%) in Primary schools?
Provide a succinct answer. 13.22. What is the difference between the highest and the lowest Gross enrolment ratio (%) in Secondary schools?
Provide a succinct answer. 37.21. What is the difference between the highest and the lowest Gross enrolment ratio (%) of Tertiary schools?
Keep it short and to the point. 74.26. 